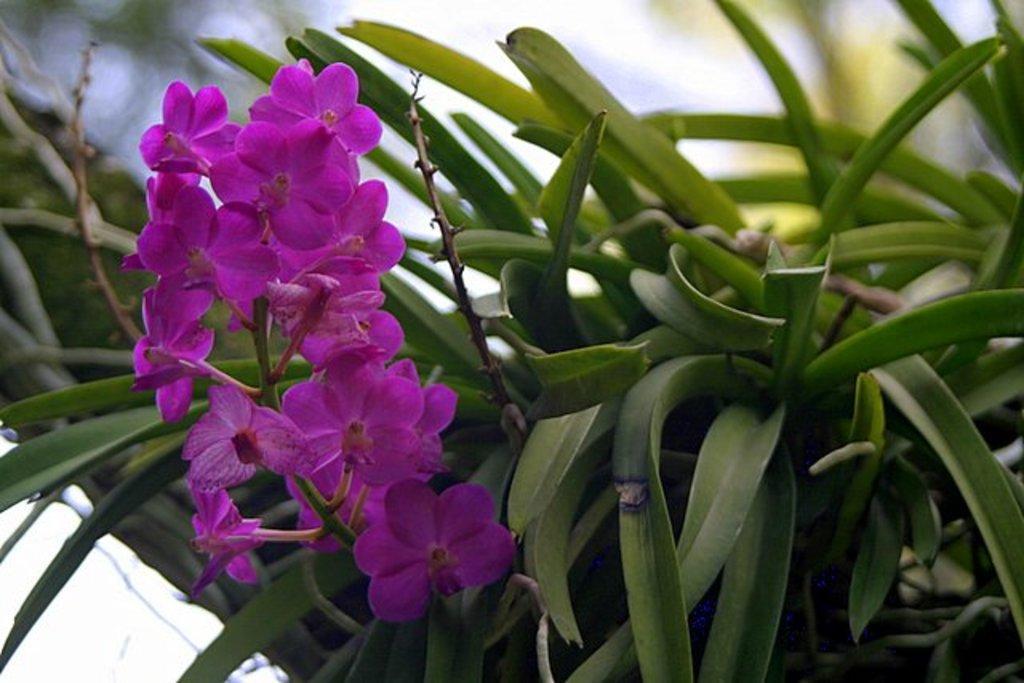Can you describe this image briefly? In the picture I can see flower plant. These flowers are purple in color. The background of the image is blurred. 